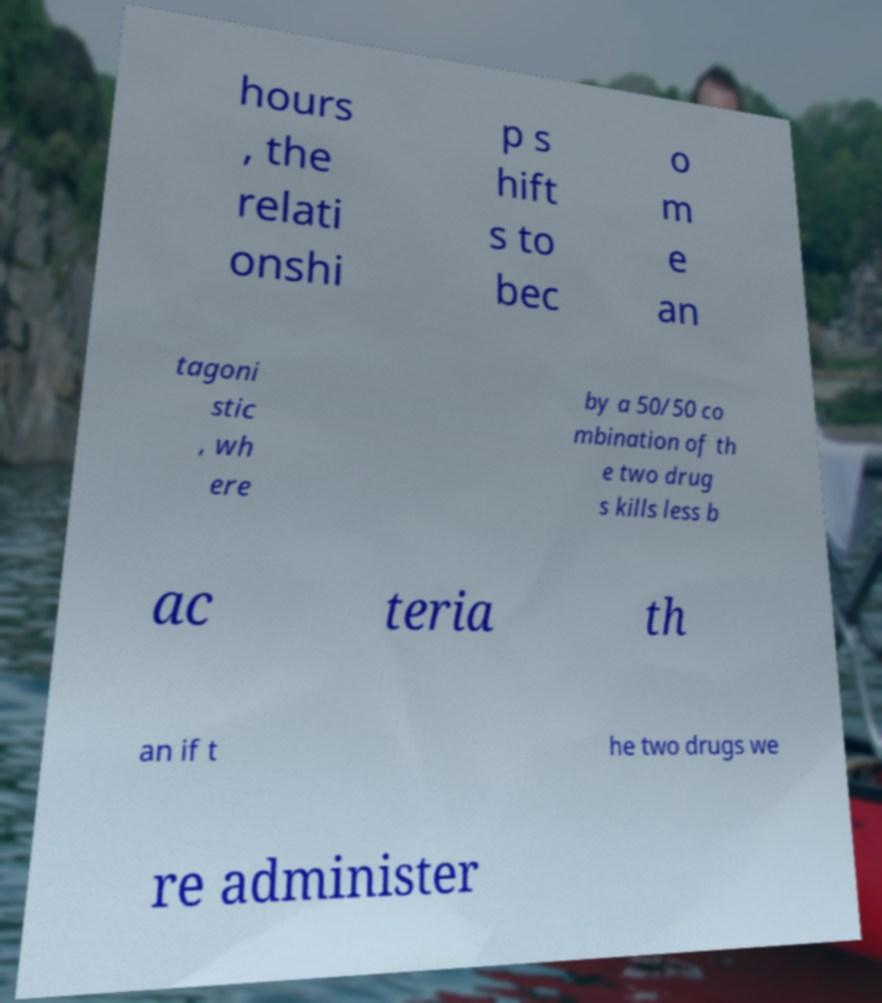I need the written content from this picture converted into text. Can you do that? hours , the relati onshi p s hift s to bec o m e an tagoni stic , wh ere by a 50/50 co mbination of th e two drug s kills less b ac teria th an if t he two drugs we re administer 